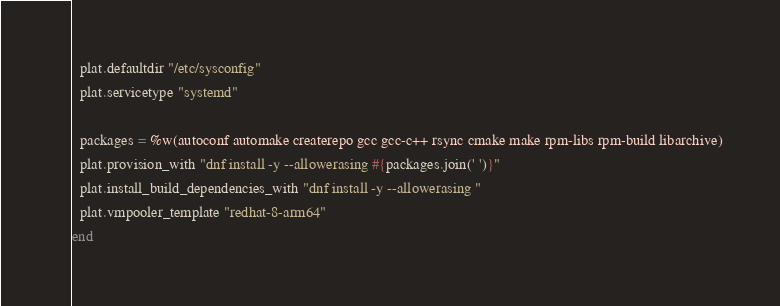<code> <loc_0><loc_0><loc_500><loc_500><_Ruby_>  plat.defaultdir "/etc/sysconfig"
  plat.servicetype "systemd"

  packages = %w(autoconf automake createrepo gcc gcc-c++ rsync cmake make rpm-libs rpm-build libarchive)
  plat.provision_with "dnf install -y --allowerasing #{packages.join(' ')}"
  plat.install_build_dependencies_with "dnf install -y --allowerasing "
  plat.vmpooler_template "redhat-8-arm64"
end
</code> 